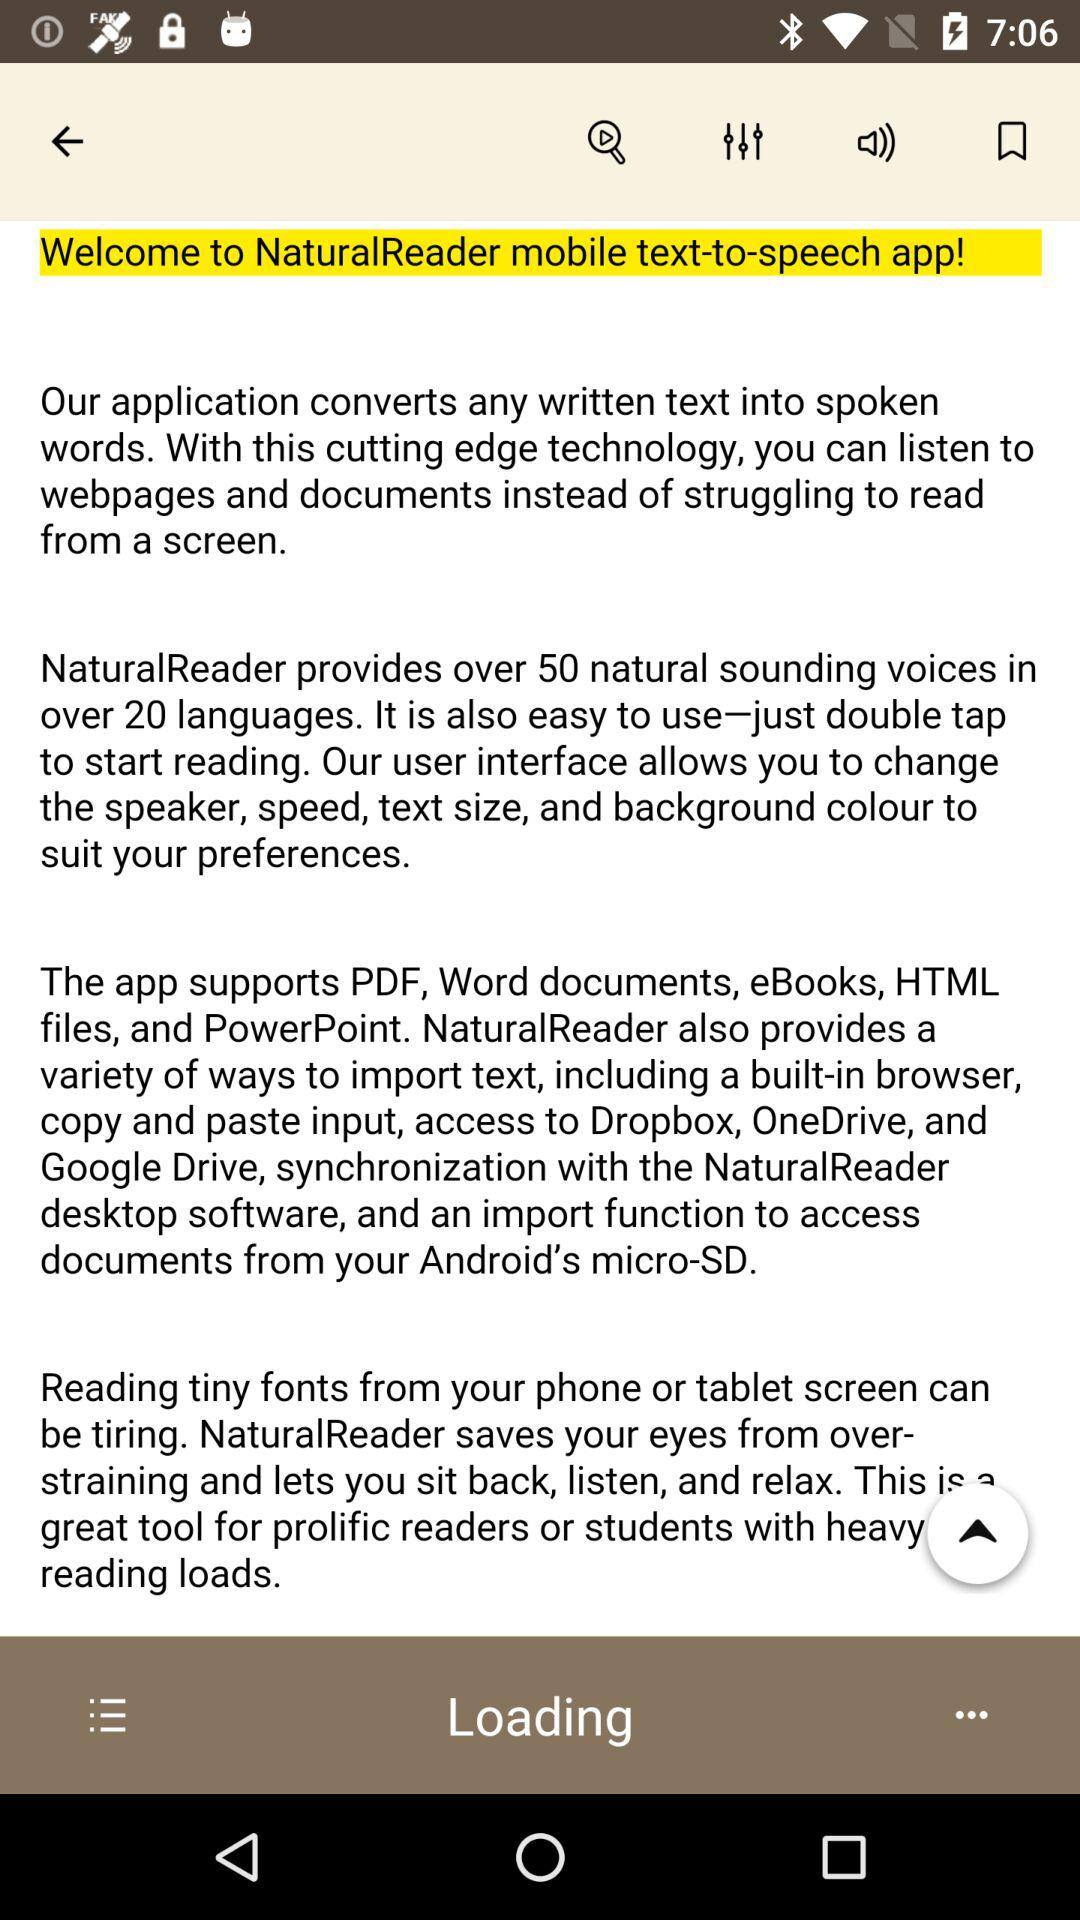In how many languages does "NaturalReader" provide voices? It provides voices in over 20 languages. 